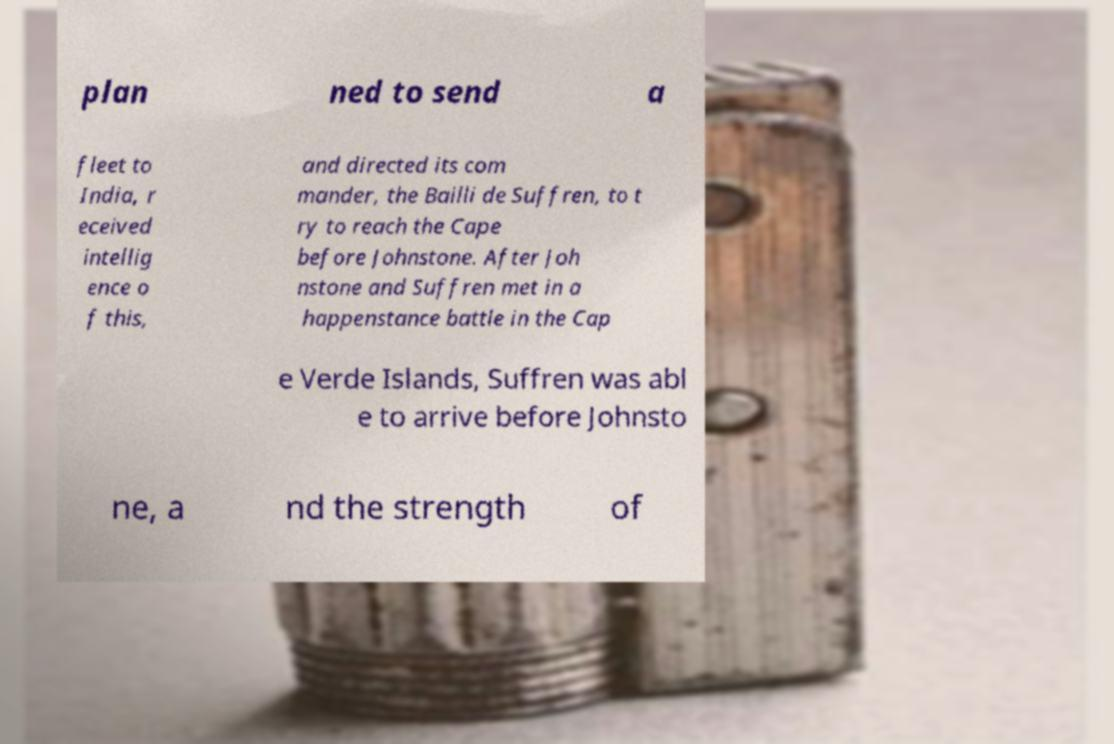Please identify and transcribe the text found in this image. plan ned to send a fleet to India, r eceived intellig ence o f this, and directed its com mander, the Bailli de Suffren, to t ry to reach the Cape before Johnstone. After Joh nstone and Suffren met in a happenstance battle in the Cap e Verde Islands, Suffren was abl e to arrive before Johnsto ne, a nd the strength of 